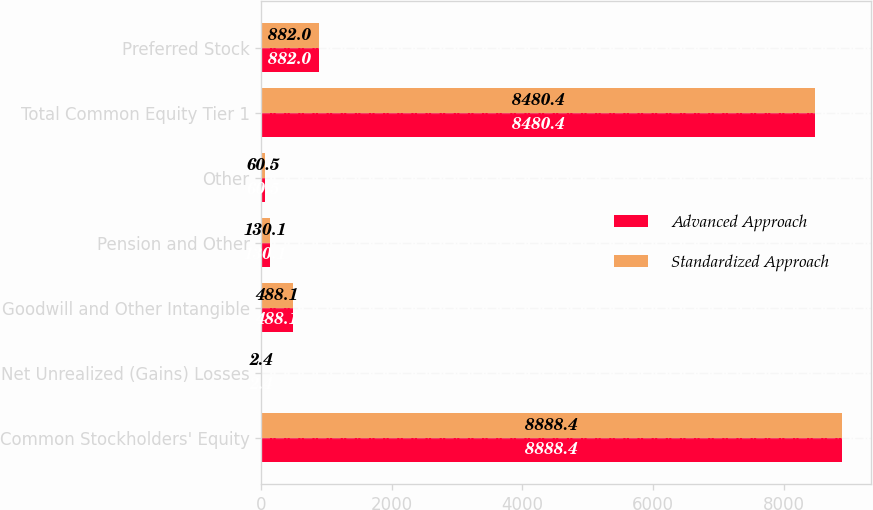Convert chart to OTSL. <chart><loc_0><loc_0><loc_500><loc_500><stacked_bar_chart><ecel><fcel>Common Stockholders' Equity<fcel>Net Unrealized (Gains) Losses<fcel>Goodwill and Other Intangible<fcel>Pension and Other<fcel>Other<fcel>Total Common Equity Tier 1<fcel>Preferred Stock<nl><fcel>Advanced Approach<fcel>8888.4<fcel>2.4<fcel>488.1<fcel>130.1<fcel>60.5<fcel>8480.4<fcel>882<nl><fcel>Standardized Approach<fcel>8888.4<fcel>2.4<fcel>488.1<fcel>130.1<fcel>60.5<fcel>8480.4<fcel>882<nl></chart> 